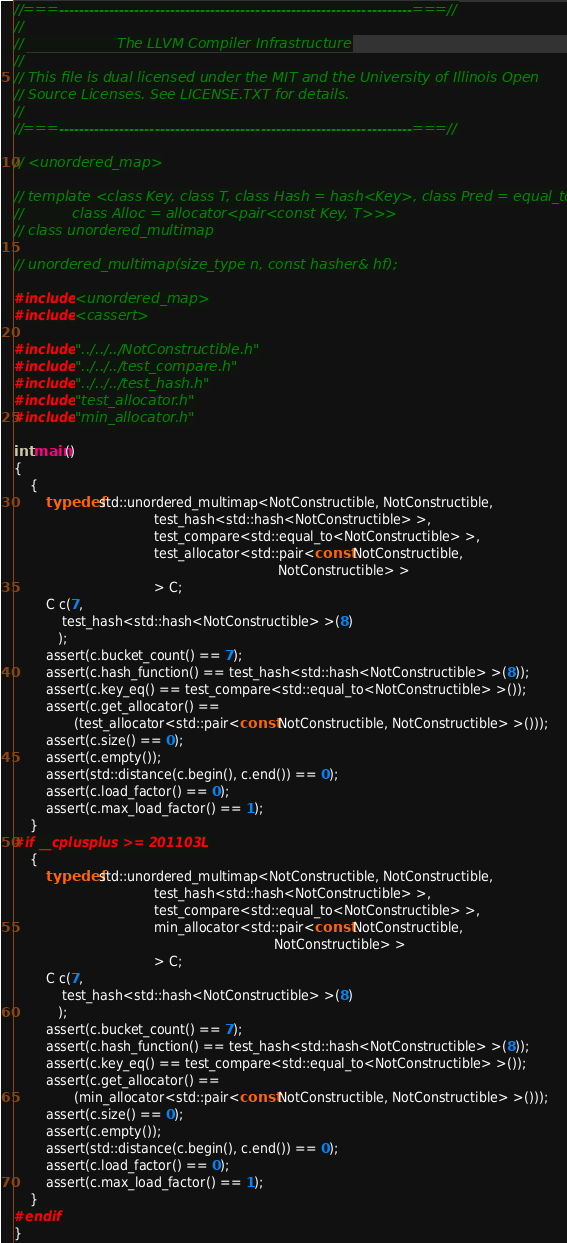<code> <loc_0><loc_0><loc_500><loc_500><_C++_>//===----------------------------------------------------------------------===//
//
//                     The LLVM Compiler Infrastructure
//
// This file is dual licensed under the MIT and the University of Illinois Open
// Source Licenses. See LICENSE.TXT for details.
//
//===----------------------------------------------------------------------===//

// <unordered_map>

// template <class Key, class T, class Hash = hash<Key>, class Pred = equal_to<Key>,
//           class Alloc = allocator<pair<const Key, T>>>
// class unordered_multimap

// unordered_multimap(size_type n, const hasher& hf);

#include <unordered_map>
#include <cassert>

#include "../../../NotConstructible.h"
#include "../../../test_compare.h"
#include "../../../test_hash.h"
#include "test_allocator.h"
#include "min_allocator.h"

int main()
{
    {
        typedef std::unordered_multimap<NotConstructible, NotConstructible,
                                   test_hash<std::hash<NotConstructible> >,
                                   test_compare<std::equal_to<NotConstructible> >,
                                   test_allocator<std::pair<const NotConstructible,
                                                                  NotConstructible> >
                                   > C;
        C c(7,
            test_hash<std::hash<NotConstructible> >(8)
           );
        assert(c.bucket_count() == 7);
        assert(c.hash_function() == test_hash<std::hash<NotConstructible> >(8));
        assert(c.key_eq() == test_compare<std::equal_to<NotConstructible> >());
        assert(c.get_allocator() ==
               (test_allocator<std::pair<const NotConstructible, NotConstructible> >()));
        assert(c.size() == 0);
        assert(c.empty());
        assert(std::distance(c.begin(), c.end()) == 0);
        assert(c.load_factor() == 0);
        assert(c.max_load_factor() == 1);
    }
#if __cplusplus >= 201103L
    {
        typedef std::unordered_multimap<NotConstructible, NotConstructible,
                                   test_hash<std::hash<NotConstructible> >,
                                   test_compare<std::equal_to<NotConstructible> >,
                                   min_allocator<std::pair<const NotConstructible,
                                                                 NotConstructible> >
                                   > C;
        C c(7,
            test_hash<std::hash<NotConstructible> >(8)
           );
        assert(c.bucket_count() == 7);
        assert(c.hash_function() == test_hash<std::hash<NotConstructible> >(8));
        assert(c.key_eq() == test_compare<std::equal_to<NotConstructible> >());
        assert(c.get_allocator() ==
               (min_allocator<std::pair<const NotConstructible, NotConstructible> >()));
        assert(c.size() == 0);
        assert(c.empty());
        assert(std::distance(c.begin(), c.end()) == 0);
        assert(c.load_factor() == 0);
        assert(c.max_load_factor() == 1);
    }
#endif
}
</code> 